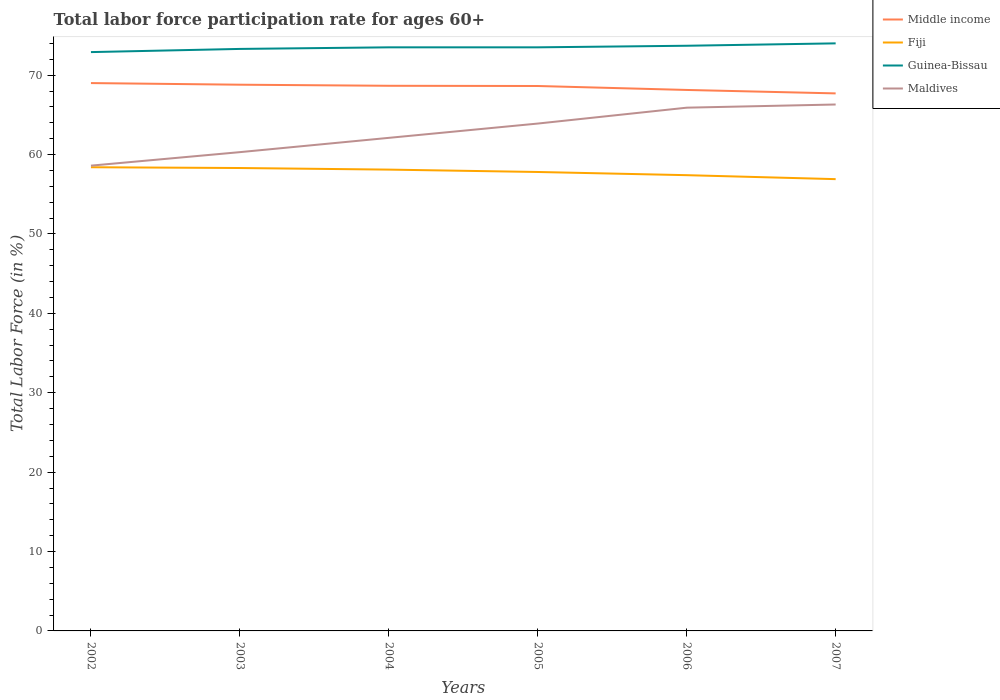How many different coloured lines are there?
Offer a terse response. 4. Across all years, what is the maximum labor force participation rate in Guinea-Bissau?
Keep it short and to the point. 72.9. What is the total labor force participation rate in Guinea-Bissau in the graph?
Your answer should be compact. -0.2. What is the difference between the highest and the second highest labor force participation rate in Maldives?
Provide a succinct answer. 7.7. What is the difference between two consecutive major ticks on the Y-axis?
Provide a short and direct response. 10. Are the values on the major ticks of Y-axis written in scientific E-notation?
Offer a very short reply. No. Does the graph contain grids?
Offer a very short reply. No. Where does the legend appear in the graph?
Provide a short and direct response. Top right. How many legend labels are there?
Keep it short and to the point. 4. What is the title of the graph?
Your answer should be compact. Total labor force participation rate for ages 60+. What is the label or title of the Y-axis?
Offer a very short reply. Total Labor Force (in %). What is the Total Labor Force (in %) of Middle income in 2002?
Provide a succinct answer. 69. What is the Total Labor Force (in %) of Fiji in 2002?
Make the answer very short. 58.4. What is the Total Labor Force (in %) of Guinea-Bissau in 2002?
Your response must be concise. 72.9. What is the Total Labor Force (in %) of Maldives in 2002?
Offer a terse response. 58.6. What is the Total Labor Force (in %) of Middle income in 2003?
Keep it short and to the point. 68.79. What is the Total Labor Force (in %) of Fiji in 2003?
Your answer should be compact. 58.3. What is the Total Labor Force (in %) of Guinea-Bissau in 2003?
Offer a very short reply. 73.3. What is the Total Labor Force (in %) of Maldives in 2003?
Your answer should be compact. 60.3. What is the Total Labor Force (in %) in Middle income in 2004?
Ensure brevity in your answer.  68.66. What is the Total Labor Force (in %) in Fiji in 2004?
Ensure brevity in your answer.  58.1. What is the Total Labor Force (in %) in Guinea-Bissau in 2004?
Ensure brevity in your answer.  73.5. What is the Total Labor Force (in %) of Maldives in 2004?
Your response must be concise. 62.1. What is the Total Labor Force (in %) of Middle income in 2005?
Provide a succinct answer. 68.63. What is the Total Labor Force (in %) in Fiji in 2005?
Provide a succinct answer. 57.8. What is the Total Labor Force (in %) of Guinea-Bissau in 2005?
Offer a very short reply. 73.5. What is the Total Labor Force (in %) of Maldives in 2005?
Offer a terse response. 63.9. What is the Total Labor Force (in %) of Middle income in 2006?
Your response must be concise. 68.13. What is the Total Labor Force (in %) of Fiji in 2006?
Keep it short and to the point. 57.4. What is the Total Labor Force (in %) in Guinea-Bissau in 2006?
Your response must be concise. 73.7. What is the Total Labor Force (in %) of Maldives in 2006?
Ensure brevity in your answer.  65.9. What is the Total Labor Force (in %) in Middle income in 2007?
Keep it short and to the point. 67.7. What is the Total Labor Force (in %) in Fiji in 2007?
Ensure brevity in your answer.  56.9. What is the Total Labor Force (in %) in Guinea-Bissau in 2007?
Keep it short and to the point. 74. What is the Total Labor Force (in %) in Maldives in 2007?
Your answer should be compact. 66.3. Across all years, what is the maximum Total Labor Force (in %) in Middle income?
Provide a succinct answer. 69. Across all years, what is the maximum Total Labor Force (in %) of Fiji?
Give a very brief answer. 58.4. Across all years, what is the maximum Total Labor Force (in %) of Guinea-Bissau?
Your answer should be compact. 74. Across all years, what is the maximum Total Labor Force (in %) of Maldives?
Offer a terse response. 66.3. Across all years, what is the minimum Total Labor Force (in %) in Middle income?
Make the answer very short. 67.7. Across all years, what is the minimum Total Labor Force (in %) in Fiji?
Offer a terse response. 56.9. Across all years, what is the minimum Total Labor Force (in %) of Guinea-Bissau?
Your response must be concise. 72.9. Across all years, what is the minimum Total Labor Force (in %) of Maldives?
Give a very brief answer. 58.6. What is the total Total Labor Force (in %) of Middle income in the graph?
Provide a succinct answer. 410.91. What is the total Total Labor Force (in %) of Fiji in the graph?
Make the answer very short. 346.9. What is the total Total Labor Force (in %) of Guinea-Bissau in the graph?
Provide a succinct answer. 440.9. What is the total Total Labor Force (in %) of Maldives in the graph?
Provide a succinct answer. 377.1. What is the difference between the Total Labor Force (in %) of Middle income in 2002 and that in 2003?
Your answer should be compact. 0.21. What is the difference between the Total Labor Force (in %) in Fiji in 2002 and that in 2003?
Ensure brevity in your answer.  0.1. What is the difference between the Total Labor Force (in %) in Maldives in 2002 and that in 2003?
Your response must be concise. -1.7. What is the difference between the Total Labor Force (in %) in Middle income in 2002 and that in 2004?
Provide a short and direct response. 0.34. What is the difference between the Total Labor Force (in %) of Maldives in 2002 and that in 2004?
Keep it short and to the point. -3.5. What is the difference between the Total Labor Force (in %) of Middle income in 2002 and that in 2005?
Ensure brevity in your answer.  0.37. What is the difference between the Total Labor Force (in %) in Guinea-Bissau in 2002 and that in 2005?
Give a very brief answer. -0.6. What is the difference between the Total Labor Force (in %) in Middle income in 2002 and that in 2006?
Provide a succinct answer. 0.87. What is the difference between the Total Labor Force (in %) of Fiji in 2002 and that in 2006?
Provide a succinct answer. 1. What is the difference between the Total Labor Force (in %) of Guinea-Bissau in 2002 and that in 2006?
Provide a succinct answer. -0.8. What is the difference between the Total Labor Force (in %) in Middle income in 2002 and that in 2007?
Your answer should be very brief. 1.3. What is the difference between the Total Labor Force (in %) in Fiji in 2002 and that in 2007?
Provide a short and direct response. 1.5. What is the difference between the Total Labor Force (in %) of Middle income in 2003 and that in 2004?
Ensure brevity in your answer.  0.14. What is the difference between the Total Labor Force (in %) of Middle income in 2003 and that in 2005?
Your response must be concise. 0.16. What is the difference between the Total Labor Force (in %) in Middle income in 2003 and that in 2006?
Keep it short and to the point. 0.66. What is the difference between the Total Labor Force (in %) of Guinea-Bissau in 2003 and that in 2006?
Make the answer very short. -0.4. What is the difference between the Total Labor Force (in %) in Middle income in 2003 and that in 2007?
Your answer should be very brief. 1.09. What is the difference between the Total Labor Force (in %) in Fiji in 2003 and that in 2007?
Give a very brief answer. 1.4. What is the difference between the Total Labor Force (in %) in Guinea-Bissau in 2003 and that in 2007?
Offer a very short reply. -0.7. What is the difference between the Total Labor Force (in %) of Middle income in 2004 and that in 2005?
Offer a terse response. 0.03. What is the difference between the Total Labor Force (in %) in Middle income in 2004 and that in 2006?
Provide a succinct answer. 0.52. What is the difference between the Total Labor Force (in %) of Fiji in 2004 and that in 2006?
Your answer should be compact. 0.7. What is the difference between the Total Labor Force (in %) of Guinea-Bissau in 2004 and that in 2006?
Keep it short and to the point. -0.2. What is the difference between the Total Labor Force (in %) in Maldives in 2004 and that in 2006?
Provide a succinct answer. -3.8. What is the difference between the Total Labor Force (in %) of Middle income in 2004 and that in 2007?
Provide a short and direct response. 0.96. What is the difference between the Total Labor Force (in %) of Guinea-Bissau in 2004 and that in 2007?
Provide a succinct answer. -0.5. What is the difference between the Total Labor Force (in %) of Maldives in 2004 and that in 2007?
Offer a very short reply. -4.2. What is the difference between the Total Labor Force (in %) of Middle income in 2005 and that in 2006?
Offer a very short reply. 0.5. What is the difference between the Total Labor Force (in %) in Maldives in 2005 and that in 2006?
Provide a succinct answer. -2. What is the difference between the Total Labor Force (in %) in Middle income in 2005 and that in 2007?
Keep it short and to the point. 0.93. What is the difference between the Total Labor Force (in %) of Fiji in 2005 and that in 2007?
Your answer should be compact. 0.9. What is the difference between the Total Labor Force (in %) in Middle income in 2006 and that in 2007?
Your answer should be compact. 0.43. What is the difference between the Total Labor Force (in %) of Fiji in 2006 and that in 2007?
Offer a terse response. 0.5. What is the difference between the Total Labor Force (in %) of Maldives in 2006 and that in 2007?
Your answer should be very brief. -0.4. What is the difference between the Total Labor Force (in %) in Middle income in 2002 and the Total Labor Force (in %) in Fiji in 2003?
Make the answer very short. 10.7. What is the difference between the Total Labor Force (in %) of Middle income in 2002 and the Total Labor Force (in %) of Guinea-Bissau in 2003?
Keep it short and to the point. -4.3. What is the difference between the Total Labor Force (in %) of Middle income in 2002 and the Total Labor Force (in %) of Maldives in 2003?
Provide a short and direct response. 8.7. What is the difference between the Total Labor Force (in %) in Fiji in 2002 and the Total Labor Force (in %) in Guinea-Bissau in 2003?
Offer a very short reply. -14.9. What is the difference between the Total Labor Force (in %) in Fiji in 2002 and the Total Labor Force (in %) in Maldives in 2003?
Your response must be concise. -1.9. What is the difference between the Total Labor Force (in %) in Guinea-Bissau in 2002 and the Total Labor Force (in %) in Maldives in 2003?
Provide a short and direct response. 12.6. What is the difference between the Total Labor Force (in %) of Middle income in 2002 and the Total Labor Force (in %) of Fiji in 2004?
Offer a very short reply. 10.9. What is the difference between the Total Labor Force (in %) in Middle income in 2002 and the Total Labor Force (in %) in Guinea-Bissau in 2004?
Offer a very short reply. -4.5. What is the difference between the Total Labor Force (in %) of Middle income in 2002 and the Total Labor Force (in %) of Maldives in 2004?
Ensure brevity in your answer.  6.9. What is the difference between the Total Labor Force (in %) in Fiji in 2002 and the Total Labor Force (in %) in Guinea-Bissau in 2004?
Ensure brevity in your answer.  -15.1. What is the difference between the Total Labor Force (in %) in Guinea-Bissau in 2002 and the Total Labor Force (in %) in Maldives in 2004?
Offer a very short reply. 10.8. What is the difference between the Total Labor Force (in %) in Middle income in 2002 and the Total Labor Force (in %) in Fiji in 2005?
Keep it short and to the point. 11.2. What is the difference between the Total Labor Force (in %) in Middle income in 2002 and the Total Labor Force (in %) in Guinea-Bissau in 2005?
Offer a terse response. -4.5. What is the difference between the Total Labor Force (in %) in Middle income in 2002 and the Total Labor Force (in %) in Maldives in 2005?
Offer a very short reply. 5.1. What is the difference between the Total Labor Force (in %) in Fiji in 2002 and the Total Labor Force (in %) in Guinea-Bissau in 2005?
Offer a terse response. -15.1. What is the difference between the Total Labor Force (in %) of Fiji in 2002 and the Total Labor Force (in %) of Maldives in 2005?
Your response must be concise. -5.5. What is the difference between the Total Labor Force (in %) of Guinea-Bissau in 2002 and the Total Labor Force (in %) of Maldives in 2005?
Ensure brevity in your answer.  9. What is the difference between the Total Labor Force (in %) of Middle income in 2002 and the Total Labor Force (in %) of Fiji in 2006?
Ensure brevity in your answer.  11.6. What is the difference between the Total Labor Force (in %) in Middle income in 2002 and the Total Labor Force (in %) in Guinea-Bissau in 2006?
Keep it short and to the point. -4.7. What is the difference between the Total Labor Force (in %) of Middle income in 2002 and the Total Labor Force (in %) of Maldives in 2006?
Offer a terse response. 3.1. What is the difference between the Total Labor Force (in %) of Fiji in 2002 and the Total Labor Force (in %) of Guinea-Bissau in 2006?
Ensure brevity in your answer.  -15.3. What is the difference between the Total Labor Force (in %) of Fiji in 2002 and the Total Labor Force (in %) of Maldives in 2006?
Your answer should be very brief. -7.5. What is the difference between the Total Labor Force (in %) of Guinea-Bissau in 2002 and the Total Labor Force (in %) of Maldives in 2006?
Offer a very short reply. 7. What is the difference between the Total Labor Force (in %) in Middle income in 2002 and the Total Labor Force (in %) in Fiji in 2007?
Ensure brevity in your answer.  12.1. What is the difference between the Total Labor Force (in %) in Middle income in 2002 and the Total Labor Force (in %) in Guinea-Bissau in 2007?
Provide a short and direct response. -5. What is the difference between the Total Labor Force (in %) of Middle income in 2002 and the Total Labor Force (in %) of Maldives in 2007?
Offer a very short reply. 2.7. What is the difference between the Total Labor Force (in %) in Fiji in 2002 and the Total Labor Force (in %) in Guinea-Bissau in 2007?
Keep it short and to the point. -15.6. What is the difference between the Total Labor Force (in %) in Fiji in 2002 and the Total Labor Force (in %) in Maldives in 2007?
Keep it short and to the point. -7.9. What is the difference between the Total Labor Force (in %) in Middle income in 2003 and the Total Labor Force (in %) in Fiji in 2004?
Ensure brevity in your answer.  10.69. What is the difference between the Total Labor Force (in %) in Middle income in 2003 and the Total Labor Force (in %) in Guinea-Bissau in 2004?
Ensure brevity in your answer.  -4.71. What is the difference between the Total Labor Force (in %) of Middle income in 2003 and the Total Labor Force (in %) of Maldives in 2004?
Offer a very short reply. 6.69. What is the difference between the Total Labor Force (in %) of Fiji in 2003 and the Total Labor Force (in %) of Guinea-Bissau in 2004?
Keep it short and to the point. -15.2. What is the difference between the Total Labor Force (in %) in Fiji in 2003 and the Total Labor Force (in %) in Maldives in 2004?
Offer a very short reply. -3.8. What is the difference between the Total Labor Force (in %) in Guinea-Bissau in 2003 and the Total Labor Force (in %) in Maldives in 2004?
Provide a short and direct response. 11.2. What is the difference between the Total Labor Force (in %) of Middle income in 2003 and the Total Labor Force (in %) of Fiji in 2005?
Offer a very short reply. 10.99. What is the difference between the Total Labor Force (in %) of Middle income in 2003 and the Total Labor Force (in %) of Guinea-Bissau in 2005?
Your answer should be compact. -4.71. What is the difference between the Total Labor Force (in %) in Middle income in 2003 and the Total Labor Force (in %) in Maldives in 2005?
Your answer should be compact. 4.89. What is the difference between the Total Labor Force (in %) in Fiji in 2003 and the Total Labor Force (in %) in Guinea-Bissau in 2005?
Provide a short and direct response. -15.2. What is the difference between the Total Labor Force (in %) in Guinea-Bissau in 2003 and the Total Labor Force (in %) in Maldives in 2005?
Give a very brief answer. 9.4. What is the difference between the Total Labor Force (in %) in Middle income in 2003 and the Total Labor Force (in %) in Fiji in 2006?
Ensure brevity in your answer.  11.39. What is the difference between the Total Labor Force (in %) of Middle income in 2003 and the Total Labor Force (in %) of Guinea-Bissau in 2006?
Your answer should be very brief. -4.91. What is the difference between the Total Labor Force (in %) in Middle income in 2003 and the Total Labor Force (in %) in Maldives in 2006?
Provide a succinct answer. 2.89. What is the difference between the Total Labor Force (in %) of Fiji in 2003 and the Total Labor Force (in %) of Guinea-Bissau in 2006?
Offer a terse response. -15.4. What is the difference between the Total Labor Force (in %) in Guinea-Bissau in 2003 and the Total Labor Force (in %) in Maldives in 2006?
Offer a very short reply. 7.4. What is the difference between the Total Labor Force (in %) of Middle income in 2003 and the Total Labor Force (in %) of Fiji in 2007?
Provide a succinct answer. 11.89. What is the difference between the Total Labor Force (in %) of Middle income in 2003 and the Total Labor Force (in %) of Guinea-Bissau in 2007?
Give a very brief answer. -5.21. What is the difference between the Total Labor Force (in %) of Middle income in 2003 and the Total Labor Force (in %) of Maldives in 2007?
Offer a terse response. 2.49. What is the difference between the Total Labor Force (in %) in Fiji in 2003 and the Total Labor Force (in %) in Guinea-Bissau in 2007?
Ensure brevity in your answer.  -15.7. What is the difference between the Total Labor Force (in %) in Fiji in 2003 and the Total Labor Force (in %) in Maldives in 2007?
Make the answer very short. -8. What is the difference between the Total Labor Force (in %) of Guinea-Bissau in 2003 and the Total Labor Force (in %) of Maldives in 2007?
Offer a very short reply. 7. What is the difference between the Total Labor Force (in %) of Middle income in 2004 and the Total Labor Force (in %) of Fiji in 2005?
Make the answer very short. 10.86. What is the difference between the Total Labor Force (in %) of Middle income in 2004 and the Total Labor Force (in %) of Guinea-Bissau in 2005?
Offer a terse response. -4.84. What is the difference between the Total Labor Force (in %) in Middle income in 2004 and the Total Labor Force (in %) in Maldives in 2005?
Ensure brevity in your answer.  4.76. What is the difference between the Total Labor Force (in %) in Fiji in 2004 and the Total Labor Force (in %) in Guinea-Bissau in 2005?
Ensure brevity in your answer.  -15.4. What is the difference between the Total Labor Force (in %) in Fiji in 2004 and the Total Labor Force (in %) in Maldives in 2005?
Provide a short and direct response. -5.8. What is the difference between the Total Labor Force (in %) in Guinea-Bissau in 2004 and the Total Labor Force (in %) in Maldives in 2005?
Provide a short and direct response. 9.6. What is the difference between the Total Labor Force (in %) in Middle income in 2004 and the Total Labor Force (in %) in Fiji in 2006?
Give a very brief answer. 11.26. What is the difference between the Total Labor Force (in %) of Middle income in 2004 and the Total Labor Force (in %) of Guinea-Bissau in 2006?
Provide a succinct answer. -5.04. What is the difference between the Total Labor Force (in %) of Middle income in 2004 and the Total Labor Force (in %) of Maldives in 2006?
Give a very brief answer. 2.76. What is the difference between the Total Labor Force (in %) in Fiji in 2004 and the Total Labor Force (in %) in Guinea-Bissau in 2006?
Your response must be concise. -15.6. What is the difference between the Total Labor Force (in %) of Fiji in 2004 and the Total Labor Force (in %) of Maldives in 2006?
Keep it short and to the point. -7.8. What is the difference between the Total Labor Force (in %) in Middle income in 2004 and the Total Labor Force (in %) in Fiji in 2007?
Your answer should be compact. 11.76. What is the difference between the Total Labor Force (in %) in Middle income in 2004 and the Total Labor Force (in %) in Guinea-Bissau in 2007?
Offer a terse response. -5.34. What is the difference between the Total Labor Force (in %) of Middle income in 2004 and the Total Labor Force (in %) of Maldives in 2007?
Your answer should be compact. 2.36. What is the difference between the Total Labor Force (in %) in Fiji in 2004 and the Total Labor Force (in %) in Guinea-Bissau in 2007?
Give a very brief answer. -15.9. What is the difference between the Total Labor Force (in %) of Fiji in 2004 and the Total Labor Force (in %) of Maldives in 2007?
Provide a succinct answer. -8.2. What is the difference between the Total Labor Force (in %) in Middle income in 2005 and the Total Labor Force (in %) in Fiji in 2006?
Provide a succinct answer. 11.23. What is the difference between the Total Labor Force (in %) in Middle income in 2005 and the Total Labor Force (in %) in Guinea-Bissau in 2006?
Offer a terse response. -5.07. What is the difference between the Total Labor Force (in %) in Middle income in 2005 and the Total Labor Force (in %) in Maldives in 2006?
Offer a very short reply. 2.73. What is the difference between the Total Labor Force (in %) in Fiji in 2005 and the Total Labor Force (in %) in Guinea-Bissau in 2006?
Your response must be concise. -15.9. What is the difference between the Total Labor Force (in %) of Fiji in 2005 and the Total Labor Force (in %) of Maldives in 2006?
Offer a terse response. -8.1. What is the difference between the Total Labor Force (in %) of Guinea-Bissau in 2005 and the Total Labor Force (in %) of Maldives in 2006?
Offer a very short reply. 7.6. What is the difference between the Total Labor Force (in %) of Middle income in 2005 and the Total Labor Force (in %) of Fiji in 2007?
Your answer should be very brief. 11.73. What is the difference between the Total Labor Force (in %) in Middle income in 2005 and the Total Labor Force (in %) in Guinea-Bissau in 2007?
Offer a very short reply. -5.37. What is the difference between the Total Labor Force (in %) of Middle income in 2005 and the Total Labor Force (in %) of Maldives in 2007?
Provide a short and direct response. 2.33. What is the difference between the Total Labor Force (in %) in Fiji in 2005 and the Total Labor Force (in %) in Guinea-Bissau in 2007?
Provide a succinct answer. -16.2. What is the difference between the Total Labor Force (in %) in Fiji in 2005 and the Total Labor Force (in %) in Maldives in 2007?
Give a very brief answer. -8.5. What is the difference between the Total Labor Force (in %) in Middle income in 2006 and the Total Labor Force (in %) in Fiji in 2007?
Make the answer very short. 11.23. What is the difference between the Total Labor Force (in %) in Middle income in 2006 and the Total Labor Force (in %) in Guinea-Bissau in 2007?
Offer a terse response. -5.87. What is the difference between the Total Labor Force (in %) in Middle income in 2006 and the Total Labor Force (in %) in Maldives in 2007?
Ensure brevity in your answer.  1.83. What is the difference between the Total Labor Force (in %) in Fiji in 2006 and the Total Labor Force (in %) in Guinea-Bissau in 2007?
Keep it short and to the point. -16.6. What is the difference between the Total Labor Force (in %) of Fiji in 2006 and the Total Labor Force (in %) of Maldives in 2007?
Keep it short and to the point. -8.9. What is the average Total Labor Force (in %) of Middle income per year?
Keep it short and to the point. 68.49. What is the average Total Labor Force (in %) of Fiji per year?
Ensure brevity in your answer.  57.82. What is the average Total Labor Force (in %) in Guinea-Bissau per year?
Offer a very short reply. 73.48. What is the average Total Labor Force (in %) of Maldives per year?
Provide a short and direct response. 62.85. In the year 2002, what is the difference between the Total Labor Force (in %) of Middle income and Total Labor Force (in %) of Fiji?
Offer a very short reply. 10.6. In the year 2002, what is the difference between the Total Labor Force (in %) in Middle income and Total Labor Force (in %) in Guinea-Bissau?
Make the answer very short. -3.9. In the year 2002, what is the difference between the Total Labor Force (in %) in Middle income and Total Labor Force (in %) in Maldives?
Offer a terse response. 10.4. In the year 2002, what is the difference between the Total Labor Force (in %) of Fiji and Total Labor Force (in %) of Guinea-Bissau?
Your answer should be compact. -14.5. In the year 2002, what is the difference between the Total Labor Force (in %) of Guinea-Bissau and Total Labor Force (in %) of Maldives?
Make the answer very short. 14.3. In the year 2003, what is the difference between the Total Labor Force (in %) in Middle income and Total Labor Force (in %) in Fiji?
Offer a terse response. 10.49. In the year 2003, what is the difference between the Total Labor Force (in %) of Middle income and Total Labor Force (in %) of Guinea-Bissau?
Your answer should be compact. -4.51. In the year 2003, what is the difference between the Total Labor Force (in %) of Middle income and Total Labor Force (in %) of Maldives?
Your answer should be very brief. 8.49. In the year 2003, what is the difference between the Total Labor Force (in %) of Guinea-Bissau and Total Labor Force (in %) of Maldives?
Provide a short and direct response. 13. In the year 2004, what is the difference between the Total Labor Force (in %) of Middle income and Total Labor Force (in %) of Fiji?
Your response must be concise. 10.56. In the year 2004, what is the difference between the Total Labor Force (in %) of Middle income and Total Labor Force (in %) of Guinea-Bissau?
Your response must be concise. -4.84. In the year 2004, what is the difference between the Total Labor Force (in %) in Middle income and Total Labor Force (in %) in Maldives?
Your response must be concise. 6.56. In the year 2004, what is the difference between the Total Labor Force (in %) of Fiji and Total Labor Force (in %) of Guinea-Bissau?
Your answer should be compact. -15.4. In the year 2004, what is the difference between the Total Labor Force (in %) of Fiji and Total Labor Force (in %) of Maldives?
Provide a succinct answer. -4. In the year 2004, what is the difference between the Total Labor Force (in %) of Guinea-Bissau and Total Labor Force (in %) of Maldives?
Offer a very short reply. 11.4. In the year 2005, what is the difference between the Total Labor Force (in %) in Middle income and Total Labor Force (in %) in Fiji?
Your answer should be very brief. 10.83. In the year 2005, what is the difference between the Total Labor Force (in %) in Middle income and Total Labor Force (in %) in Guinea-Bissau?
Your answer should be compact. -4.87. In the year 2005, what is the difference between the Total Labor Force (in %) of Middle income and Total Labor Force (in %) of Maldives?
Your answer should be compact. 4.73. In the year 2005, what is the difference between the Total Labor Force (in %) of Fiji and Total Labor Force (in %) of Guinea-Bissau?
Make the answer very short. -15.7. In the year 2005, what is the difference between the Total Labor Force (in %) in Fiji and Total Labor Force (in %) in Maldives?
Offer a very short reply. -6.1. In the year 2006, what is the difference between the Total Labor Force (in %) in Middle income and Total Labor Force (in %) in Fiji?
Your answer should be very brief. 10.73. In the year 2006, what is the difference between the Total Labor Force (in %) of Middle income and Total Labor Force (in %) of Guinea-Bissau?
Ensure brevity in your answer.  -5.57. In the year 2006, what is the difference between the Total Labor Force (in %) in Middle income and Total Labor Force (in %) in Maldives?
Provide a short and direct response. 2.23. In the year 2006, what is the difference between the Total Labor Force (in %) in Fiji and Total Labor Force (in %) in Guinea-Bissau?
Ensure brevity in your answer.  -16.3. In the year 2006, what is the difference between the Total Labor Force (in %) of Fiji and Total Labor Force (in %) of Maldives?
Ensure brevity in your answer.  -8.5. In the year 2007, what is the difference between the Total Labor Force (in %) of Middle income and Total Labor Force (in %) of Fiji?
Offer a terse response. 10.8. In the year 2007, what is the difference between the Total Labor Force (in %) in Middle income and Total Labor Force (in %) in Guinea-Bissau?
Provide a succinct answer. -6.3. In the year 2007, what is the difference between the Total Labor Force (in %) of Middle income and Total Labor Force (in %) of Maldives?
Provide a short and direct response. 1.4. In the year 2007, what is the difference between the Total Labor Force (in %) in Fiji and Total Labor Force (in %) in Guinea-Bissau?
Your answer should be compact. -17.1. In the year 2007, what is the difference between the Total Labor Force (in %) of Fiji and Total Labor Force (in %) of Maldives?
Make the answer very short. -9.4. In the year 2007, what is the difference between the Total Labor Force (in %) in Guinea-Bissau and Total Labor Force (in %) in Maldives?
Make the answer very short. 7.7. What is the ratio of the Total Labor Force (in %) in Middle income in 2002 to that in 2003?
Offer a terse response. 1. What is the ratio of the Total Labor Force (in %) of Guinea-Bissau in 2002 to that in 2003?
Your answer should be compact. 0.99. What is the ratio of the Total Labor Force (in %) of Maldives in 2002 to that in 2003?
Provide a succinct answer. 0.97. What is the ratio of the Total Labor Force (in %) of Middle income in 2002 to that in 2004?
Give a very brief answer. 1. What is the ratio of the Total Labor Force (in %) in Fiji in 2002 to that in 2004?
Your answer should be very brief. 1.01. What is the ratio of the Total Labor Force (in %) in Maldives in 2002 to that in 2004?
Your answer should be very brief. 0.94. What is the ratio of the Total Labor Force (in %) of Middle income in 2002 to that in 2005?
Provide a succinct answer. 1.01. What is the ratio of the Total Labor Force (in %) in Fiji in 2002 to that in 2005?
Your answer should be very brief. 1.01. What is the ratio of the Total Labor Force (in %) of Maldives in 2002 to that in 2005?
Offer a very short reply. 0.92. What is the ratio of the Total Labor Force (in %) of Middle income in 2002 to that in 2006?
Give a very brief answer. 1.01. What is the ratio of the Total Labor Force (in %) in Fiji in 2002 to that in 2006?
Provide a succinct answer. 1.02. What is the ratio of the Total Labor Force (in %) of Maldives in 2002 to that in 2006?
Your answer should be very brief. 0.89. What is the ratio of the Total Labor Force (in %) of Middle income in 2002 to that in 2007?
Provide a succinct answer. 1.02. What is the ratio of the Total Labor Force (in %) of Fiji in 2002 to that in 2007?
Give a very brief answer. 1.03. What is the ratio of the Total Labor Force (in %) of Guinea-Bissau in 2002 to that in 2007?
Your response must be concise. 0.99. What is the ratio of the Total Labor Force (in %) in Maldives in 2002 to that in 2007?
Give a very brief answer. 0.88. What is the ratio of the Total Labor Force (in %) in Guinea-Bissau in 2003 to that in 2004?
Ensure brevity in your answer.  1. What is the ratio of the Total Labor Force (in %) of Maldives in 2003 to that in 2004?
Your response must be concise. 0.97. What is the ratio of the Total Labor Force (in %) in Fiji in 2003 to that in 2005?
Your response must be concise. 1.01. What is the ratio of the Total Labor Force (in %) in Maldives in 2003 to that in 2005?
Offer a very short reply. 0.94. What is the ratio of the Total Labor Force (in %) in Middle income in 2003 to that in 2006?
Keep it short and to the point. 1.01. What is the ratio of the Total Labor Force (in %) in Fiji in 2003 to that in 2006?
Keep it short and to the point. 1.02. What is the ratio of the Total Labor Force (in %) of Guinea-Bissau in 2003 to that in 2006?
Your answer should be very brief. 0.99. What is the ratio of the Total Labor Force (in %) in Maldives in 2003 to that in 2006?
Your answer should be compact. 0.92. What is the ratio of the Total Labor Force (in %) in Middle income in 2003 to that in 2007?
Make the answer very short. 1.02. What is the ratio of the Total Labor Force (in %) in Fiji in 2003 to that in 2007?
Make the answer very short. 1.02. What is the ratio of the Total Labor Force (in %) in Guinea-Bissau in 2003 to that in 2007?
Make the answer very short. 0.99. What is the ratio of the Total Labor Force (in %) in Maldives in 2003 to that in 2007?
Ensure brevity in your answer.  0.91. What is the ratio of the Total Labor Force (in %) of Middle income in 2004 to that in 2005?
Your response must be concise. 1. What is the ratio of the Total Labor Force (in %) in Fiji in 2004 to that in 2005?
Your response must be concise. 1.01. What is the ratio of the Total Labor Force (in %) of Guinea-Bissau in 2004 to that in 2005?
Offer a terse response. 1. What is the ratio of the Total Labor Force (in %) of Maldives in 2004 to that in 2005?
Your response must be concise. 0.97. What is the ratio of the Total Labor Force (in %) in Middle income in 2004 to that in 2006?
Provide a short and direct response. 1.01. What is the ratio of the Total Labor Force (in %) of Fiji in 2004 to that in 2006?
Your answer should be compact. 1.01. What is the ratio of the Total Labor Force (in %) of Guinea-Bissau in 2004 to that in 2006?
Provide a short and direct response. 1. What is the ratio of the Total Labor Force (in %) of Maldives in 2004 to that in 2006?
Give a very brief answer. 0.94. What is the ratio of the Total Labor Force (in %) in Middle income in 2004 to that in 2007?
Your response must be concise. 1.01. What is the ratio of the Total Labor Force (in %) of Fiji in 2004 to that in 2007?
Your response must be concise. 1.02. What is the ratio of the Total Labor Force (in %) in Maldives in 2004 to that in 2007?
Keep it short and to the point. 0.94. What is the ratio of the Total Labor Force (in %) of Middle income in 2005 to that in 2006?
Provide a succinct answer. 1.01. What is the ratio of the Total Labor Force (in %) of Fiji in 2005 to that in 2006?
Provide a short and direct response. 1.01. What is the ratio of the Total Labor Force (in %) of Guinea-Bissau in 2005 to that in 2006?
Your answer should be compact. 1. What is the ratio of the Total Labor Force (in %) in Maldives in 2005 to that in 2006?
Your response must be concise. 0.97. What is the ratio of the Total Labor Force (in %) in Middle income in 2005 to that in 2007?
Offer a very short reply. 1.01. What is the ratio of the Total Labor Force (in %) in Fiji in 2005 to that in 2007?
Give a very brief answer. 1.02. What is the ratio of the Total Labor Force (in %) of Maldives in 2005 to that in 2007?
Provide a succinct answer. 0.96. What is the ratio of the Total Labor Force (in %) of Middle income in 2006 to that in 2007?
Your answer should be compact. 1.01. What is the ratio of the Total Labor Force (in %) in Fiji in 2006 to that in 2007?
Provide a short and direct response. 1.01. What is the ratio of the Total Labor Force (in %) in Guinea-Bissau in 2006 to that in 2007?
Ensure brevity in your answer.  1. What is the difference between the highest and the second highest Total Labor Force (in %) in Middle income?
Give a very brief answer. 0.21. What is the difference between the highest and the lowest Total Labor Force (in %) in Middle income?
Keep it short and to the point. 1.3. What is the difference between the highest and the lowest Total Labor Force (in %) in Fiji?
Your answer should be compact. 1.5. What is the difference between the highest and the lowest Total Labor Force (in %) of Maldives?
Your response must be concise. 7.7. 